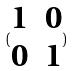<formula> <loc_0><loc_0><loc_500><loc_500>( \begin{matrix} 1 & 0 \\ 0 & 1 \end{matrix} )</formula> 